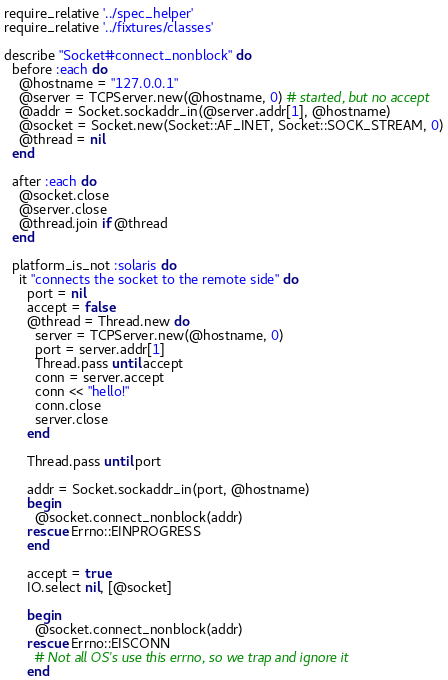Convert code to text. <code><loc_0><loc_0><loc_500><loc_500><_Ruby_>require_relative '../spec_helper'
require_relative '../fixtures/classes'

describe "Socket#connect_nonblock" do
  before :each do
    @hostname = "127.0.0.1"
    @server = TCPServer.new(@hostname, 0) # started, but no accept
    @addr = Socket.sockaddr_in(@server.addr[1], @hostname)
    @socket = Socket.new(Socket::AF_INET, Socket::SOCK_STREAM, 0)
    @thread = nil
  end

  after :each do
    @socket.close
    @server.close
    @thread.join if @thread
  end

  platform_is_not :solaris do
    it "connects the socket to the remote side" do
      port = nil
      accept = false
      @thread = Thread.new do
        server = TCPServer.new(@hostname, 0)
        port = server.addr[1]
        Thread.pass until accept
        conn = server.accept
        conn << "hello!"
        conn.close
        server.close
      end

      Thread.pass until port

      addr = Socket.sockaddr_in(port, @hostname)
      begin
        @socket.connect_nonblock(addr)
      rescue Errno::EINPROGRESS
      end

      accept = true
      IO.select nil, [@socket]

      begin
        @socket.connect_nonblock(addr)
      rescue Errno::EISCONN
        # Not all OS's use this errno, so we trap and ignore it
      end
</code> 